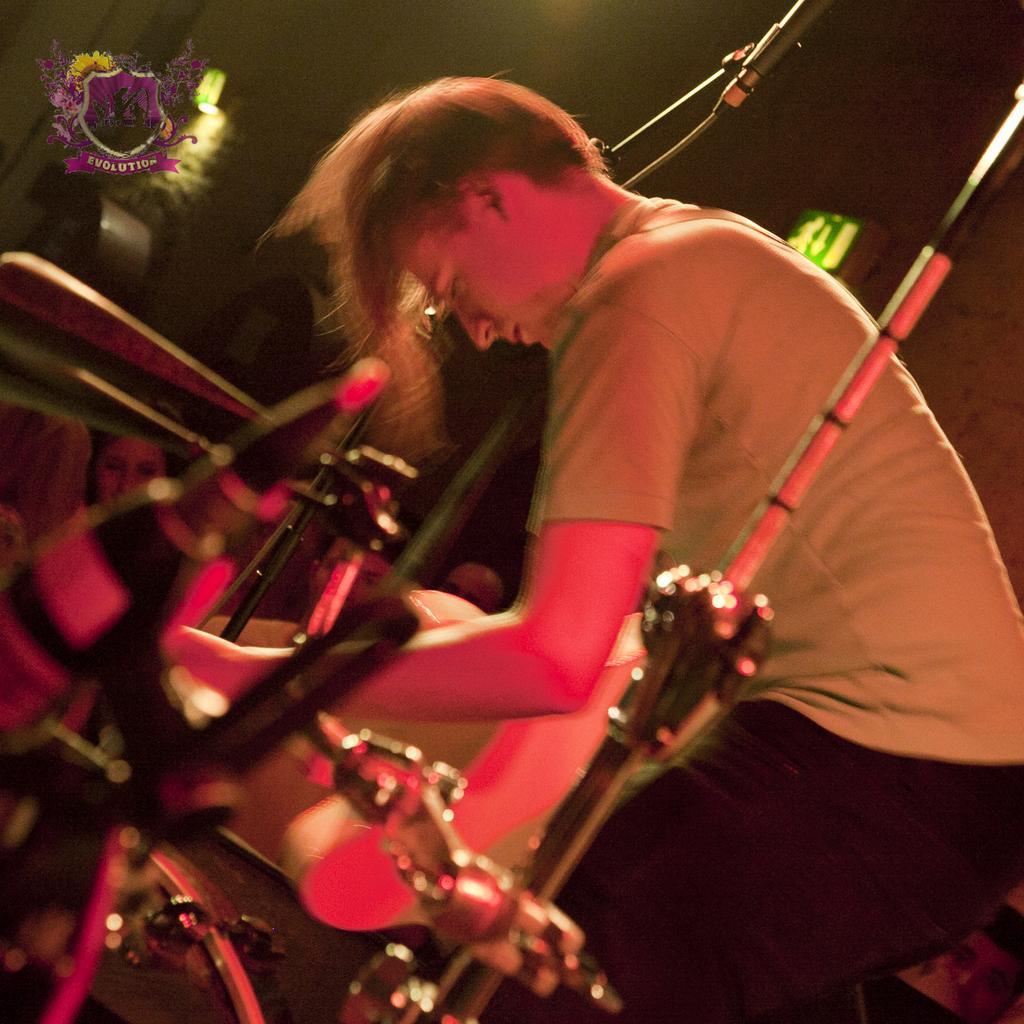Can you describe this image briefly? In this image on the right, there is a man, he wears a t shirt, trouser. In the middle there are musical instruments, mics. In the background there are people, sign boards, lights, logo and text. 